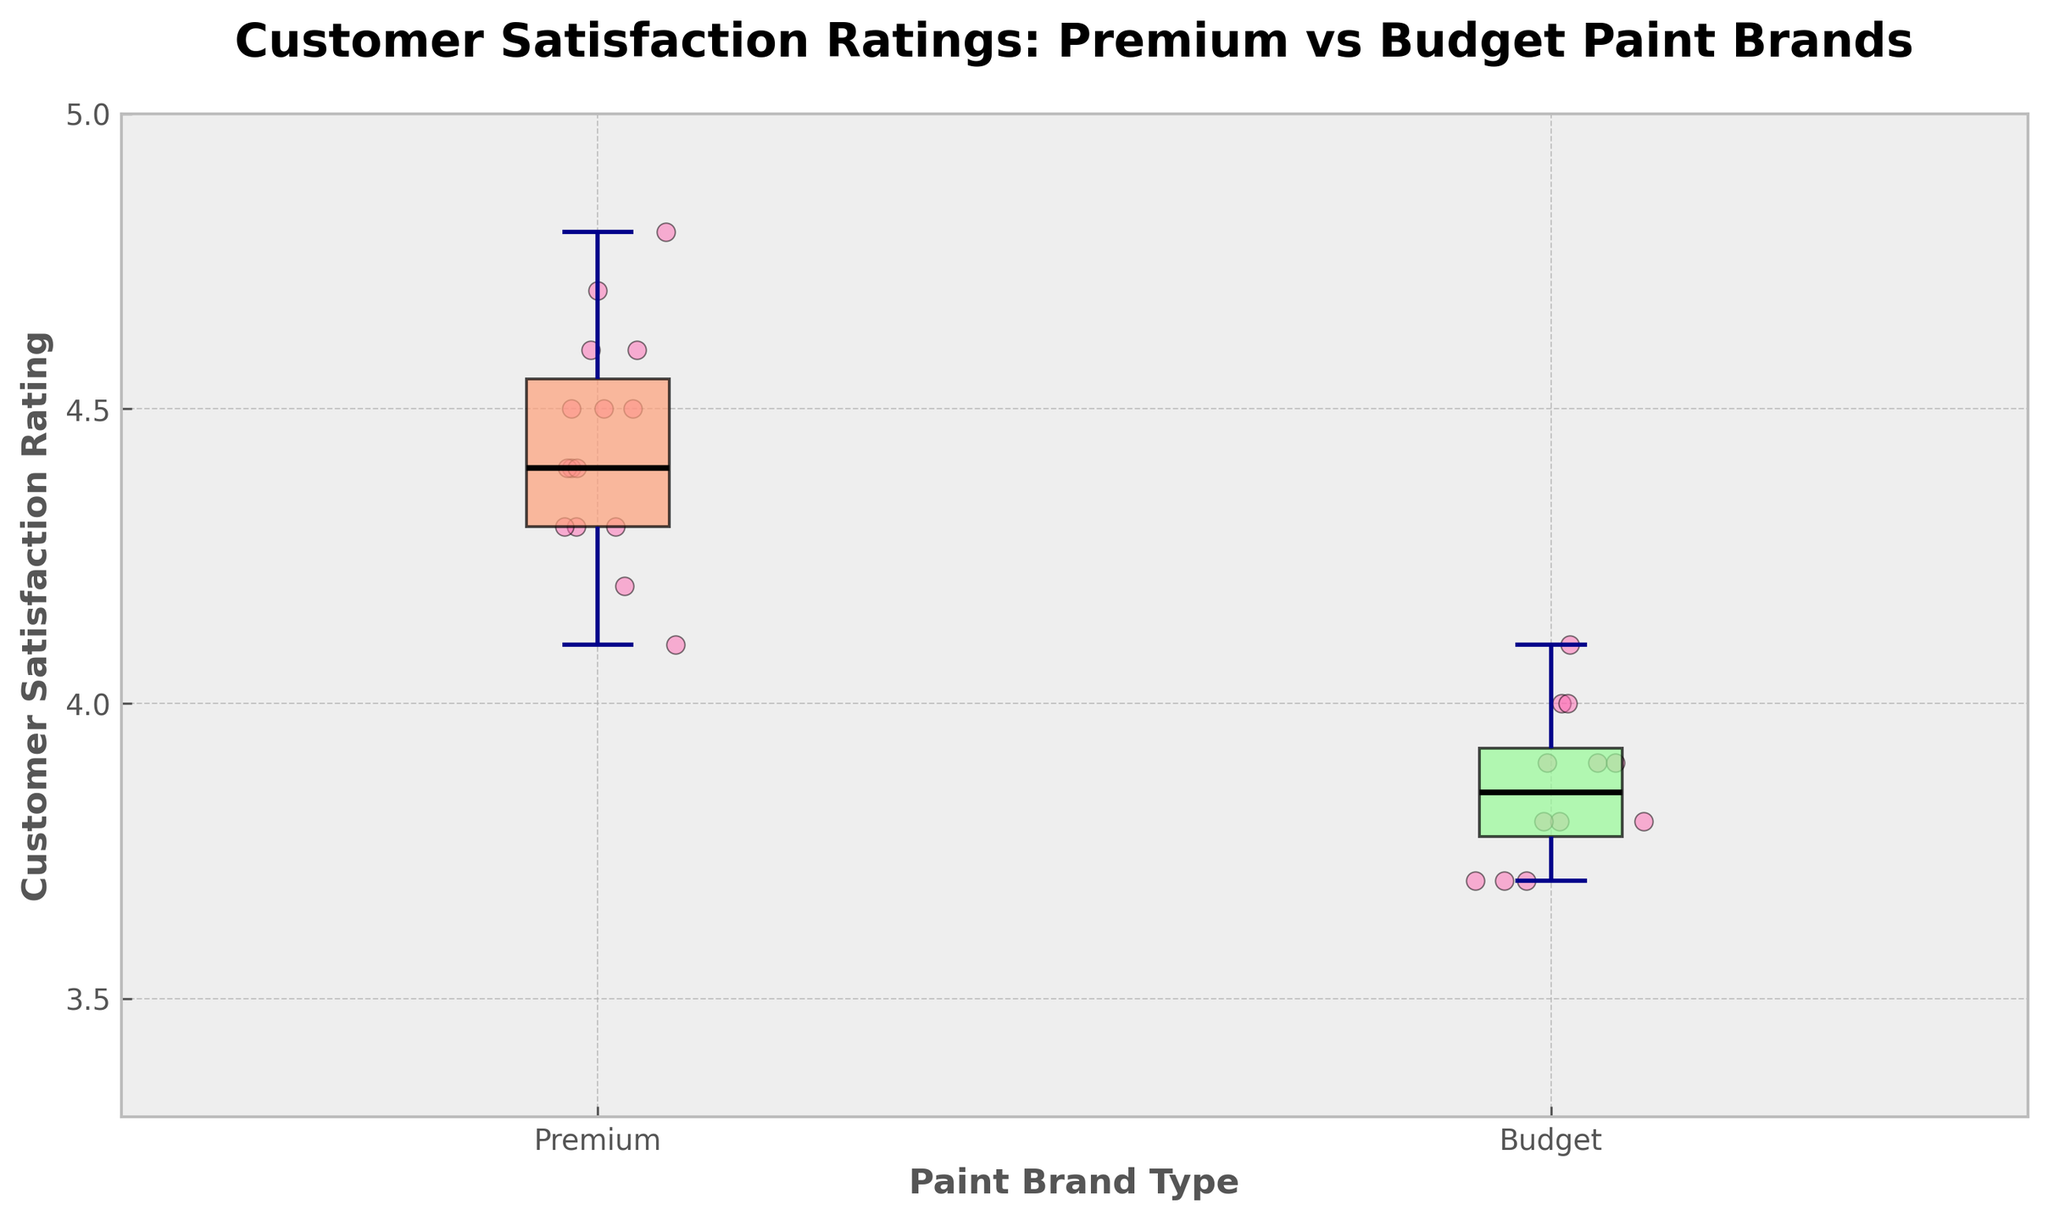What is the title of the plot? The title is located at the top of the figure in bold font, displaying 'Customer Satisfaction Ratings: Premium vs Budget Paint Brands'.
Answer: Customer Satisfaction Ratings: Premium vs Budget Paint Brands What are the labels on the x-axis? The x-axis labels are found below the box plots and indicate the two groups being compared: 'Premium' and 'Budget'.
Answer: Premium, Budget What is the color of the 'Budget' box? The color of the 'Budget' box is a light green shade. This is because the box colors were customized for visual clarity.
Answer: Light green What is the median customer satisfaction rating for 'Premium' paints? The median line inside the 'Premium' paint box represents the middle value of the data set. As indicated by the position of the line within the box, the median is at 4.4.
Answer: 4.4 Which paint type has a higher median customer satisfaction rating? By comparing the positions of the medians in both boxes on the y-axis, it's clear that the 'Premium' box has a higher median at 4.4 compared to the 'Budget' box's median.
Answer: Premium What is the interquartile range (IQR) for 'Premium' paint brands? The IQR is the range between the first quartile (Q1) and the third quartile (Q3) within the 'Premium' box. Observing the box, Q1 is at 4.3 and Q3 is at 4.6, so the IQR is 4.6 - 4.3.
Answer: 0.3 How many outliers does each box plot show? Each box plot does not appear to have dots or points outside the whiskers, indicating no outliers. This can be inferred from the absence of markers outside the whiskers.
Answer: None for both Are the customer satisfaction ratings more varied for 'Premium' or 'Budget' paints? The variation is indicated by the spread of the box plots. The 'Budget' box is larger and the whiskers are longer, suggesting greater variability in customer satisfaction ratings compared to the narrower 'Premium' box.
Answer: Budget What is the lowest customer satisfaction rating for 'Premium' paints? The lower whisker of the 'Premium' box plot indicates the minimum value, which is at 4.1, reflecting the lowest customer satisfaction rating for this category.
Answer: 4.1 What is the range of customer satisfaction ratings for 'Budget' paint brands? The range is found by subtracting the minimum value from the maximum value within the 'Budget' box plot. The lowest value is around 3.5 and the highest is around 4.1: 4.1 - 3.5.
Answer: 0.6 